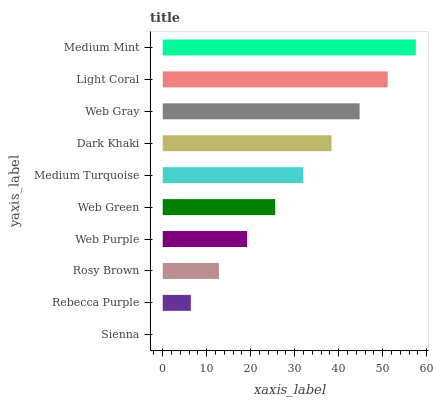Is Sienna the minimum?
Answer yes or no. Yes. Is Medium Mint the maximum?
Answer yes or no. Yes. Is Rebecca Purple the minimum?
Answer yes or no. No. Is Rebecca Purple the maximum?
Answer yes or no. No. Is Rebecca Purple greater than Sienna?
Answer yes or no. Yes. Is Sienna less than Rebecca Purple?
Answer yes or no. Yes. Is Sienna greater than Rebecca Purple?
Answer yes or no. No. Is Rebecca Purple less than Sienna?
Answer yes or no. No. Is Medium Turquoise the high median?
Answer yes or no. Yes. Is Web Green the low median?
Answer yes or no. Yes. Is Rebecca Purple the high median?
Answer yes or no. No. Is Web Gray the low median?
Answer yes or no. No. 